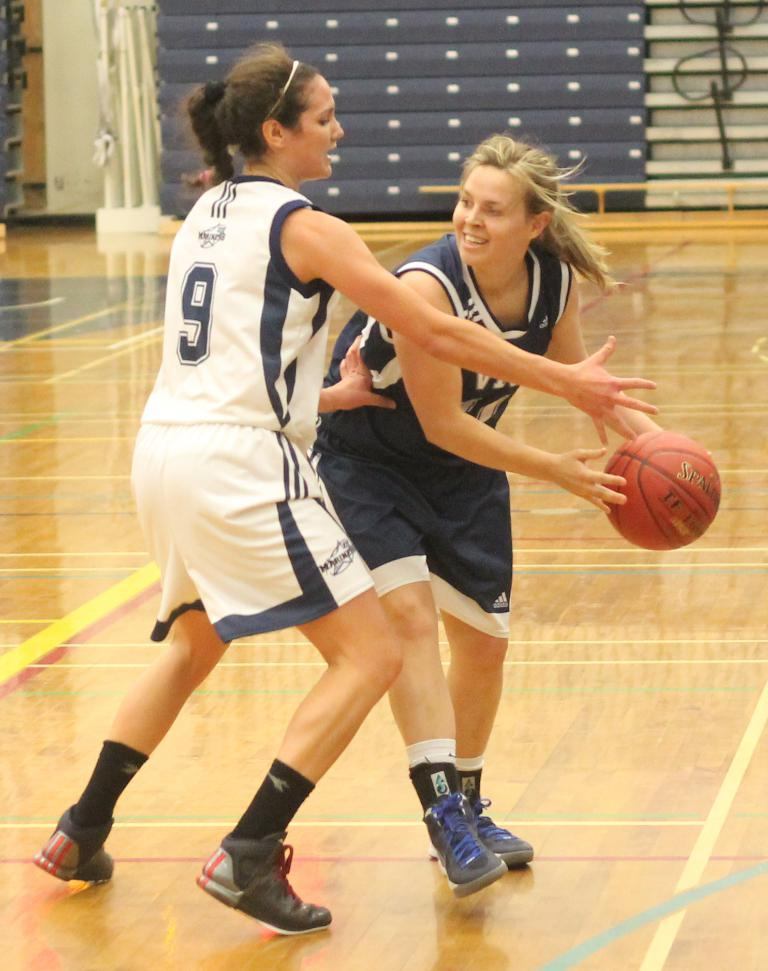<image>
Write a terse but informative summary of the picture. Player number 9 in the white uniform is trying to block the other player. 